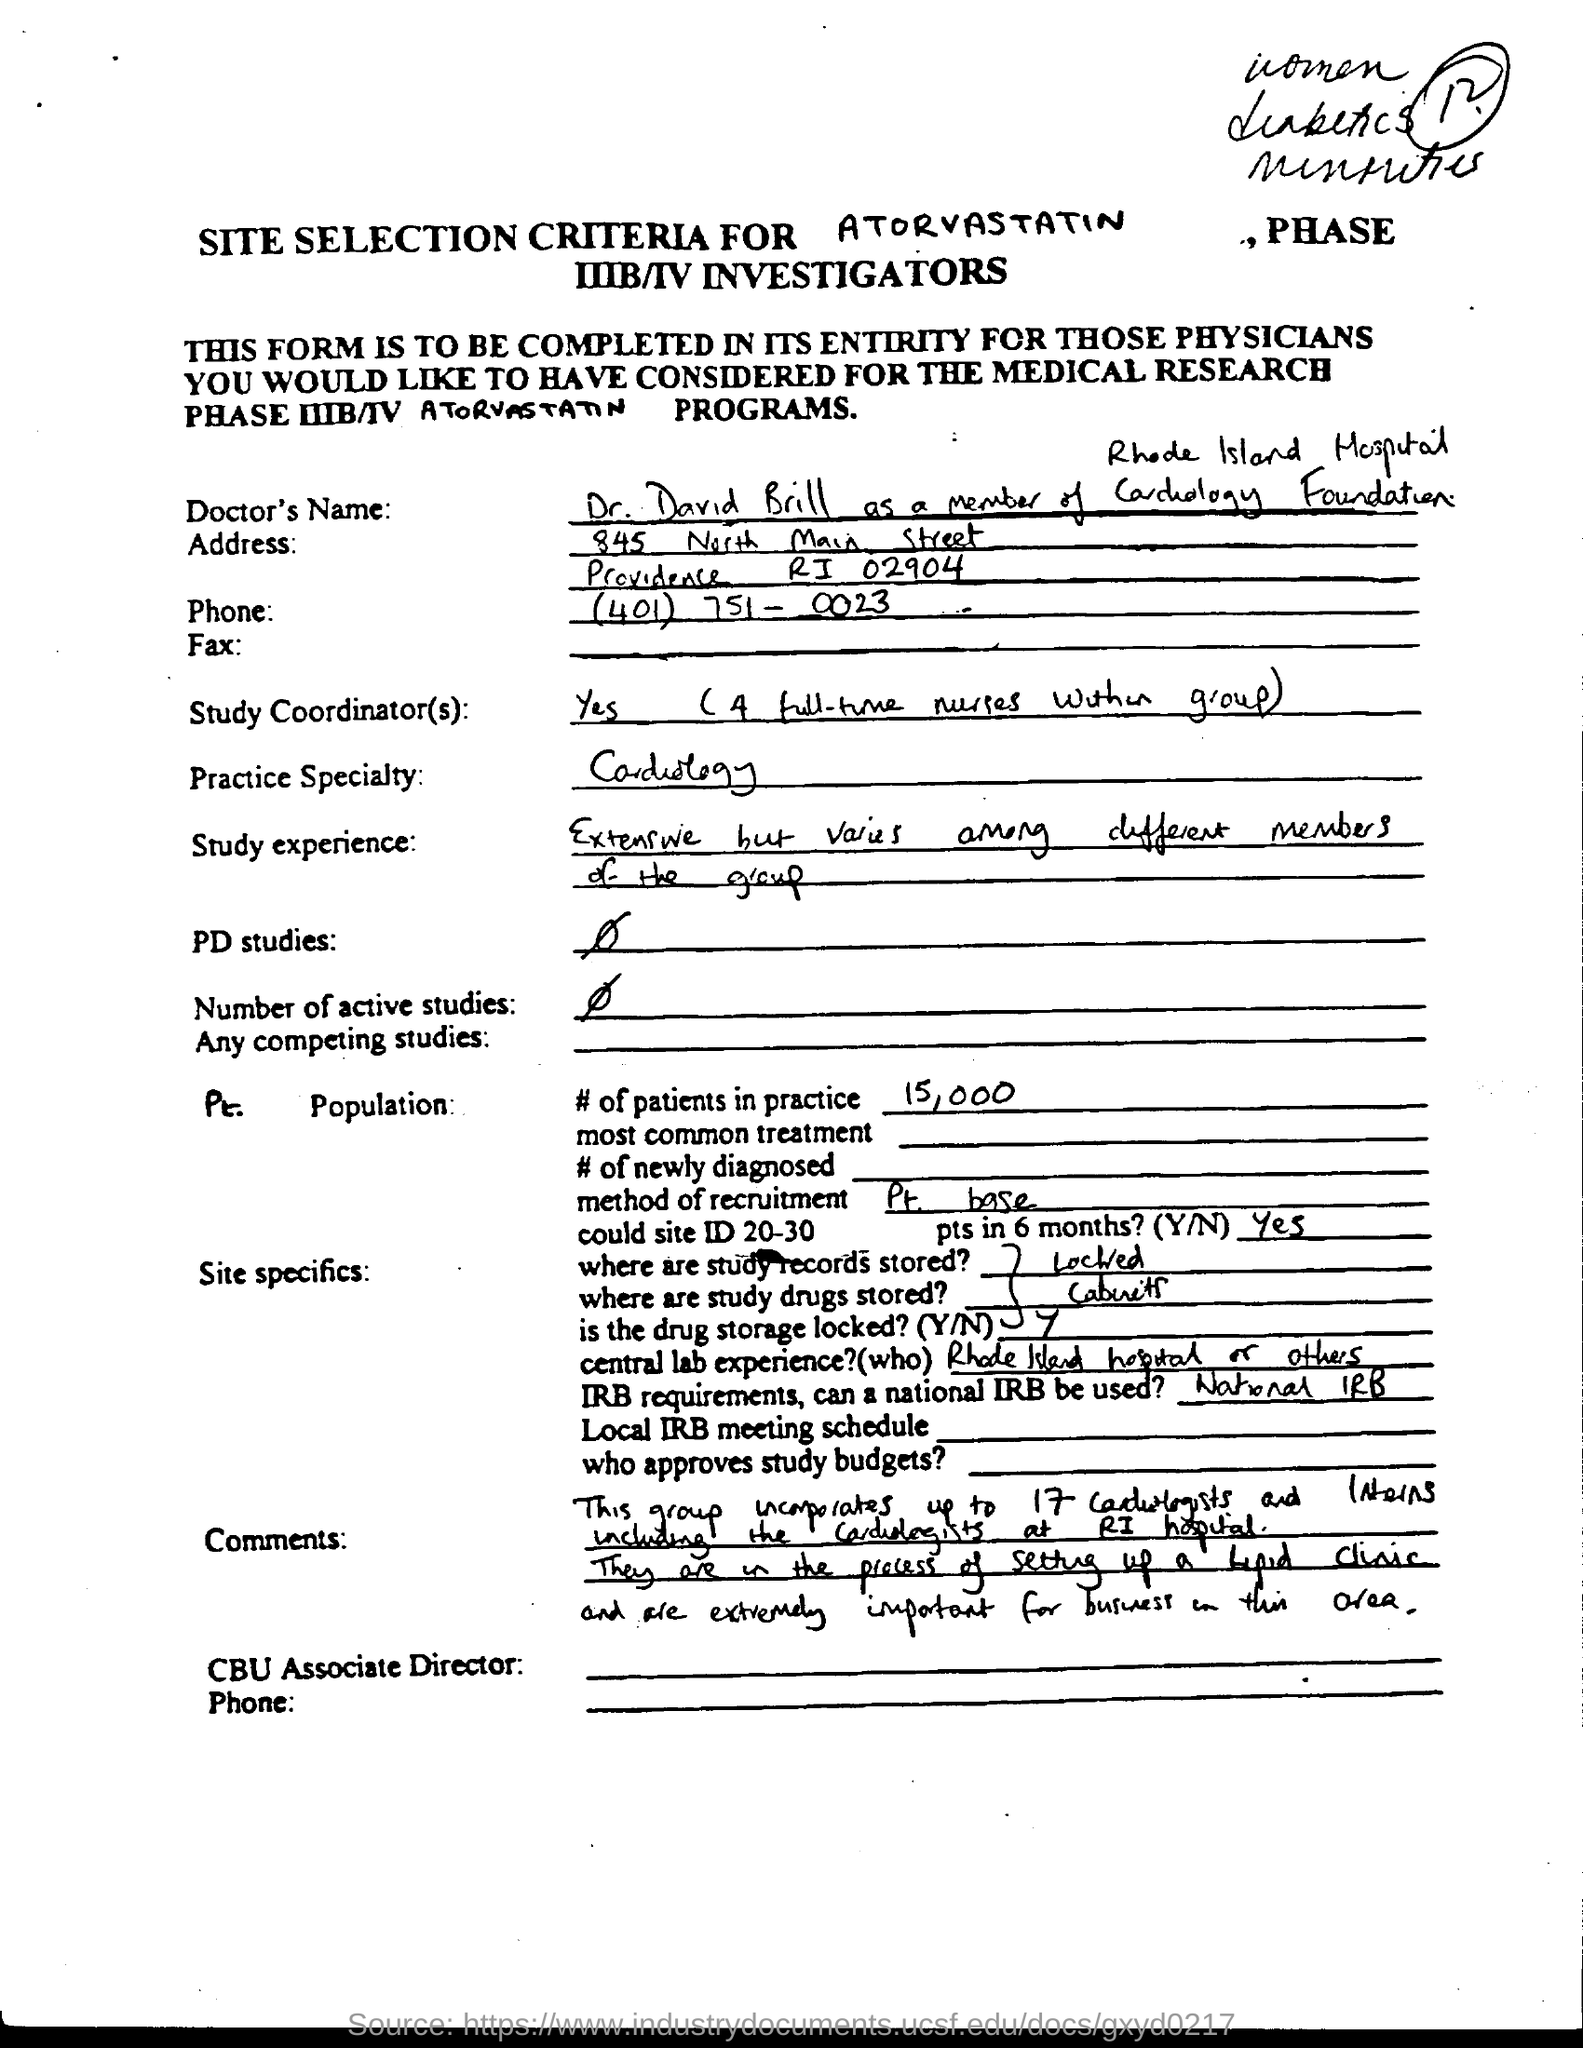What is the Doctor's name?
Your response must be concise. Dr. David Brill. What is the Practice speciality?
Give a very brief answer. Cardiology. What are the # of patients in practice?
Provide a succinct answer. 15,000. What is the method of recruitment?
Provide a succinct answer. Pt base. Is the drug storage locked(Y/N)?
Keep it short and to the point. Y. 